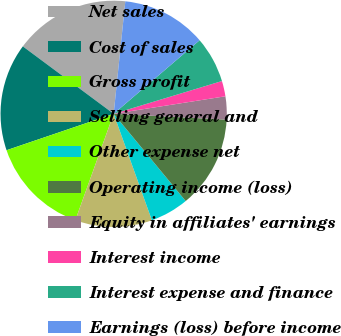Convert chart to OTSL. <chart><loc_0><loc_0><loc_500><loc_500><pie_chart><fcel>Net sales<fcel>Cost of sales<fcel>Gross profit<fcel>Selling general and<fcel>Other expense net<fcel>Operating income (loss)<fcel>Equity in affiliates' earnings<fcel>Interest income<fcel>Interest expense and finance<fcel>Earnings (loss) before income<nl><fcel>16.48%<fcel>15.38%<fcel>14.28%<fcel>10.99%<fcel>5.5%<fcel>13.19%<fcel>3.3%<fcel>2.2%<fcel>6.59%<fcel>12.09%<nl></chart> 